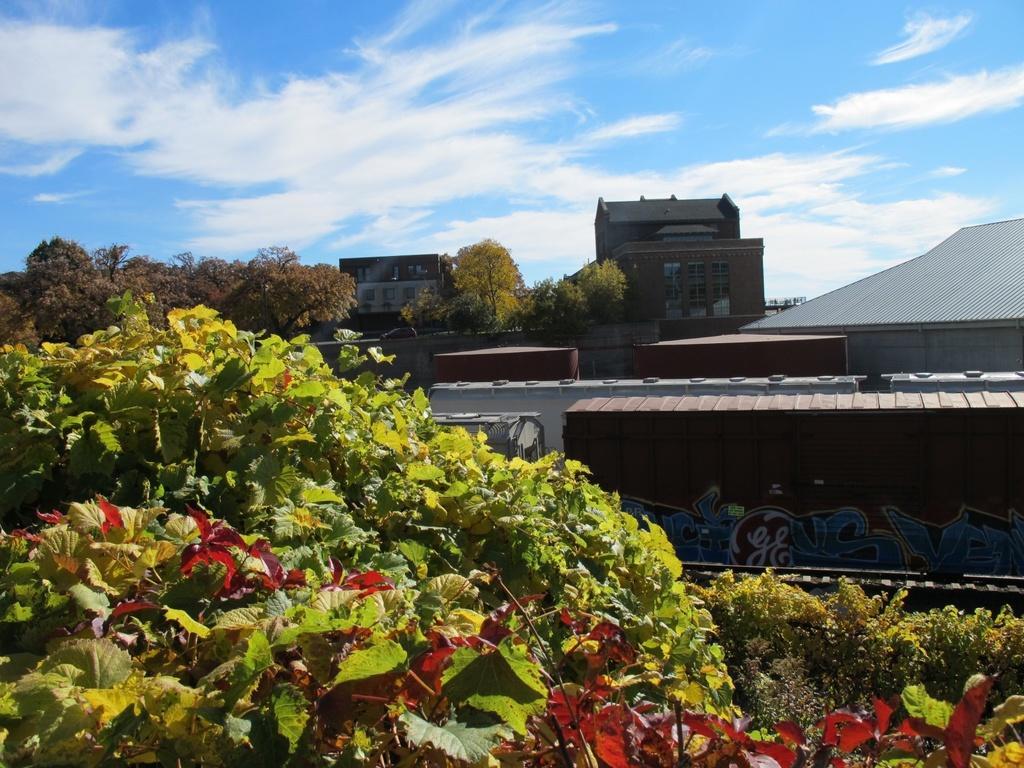Can you describe this image briefly? In this image , in the foreground there are many leaves and on the left side there is a tree and the background is the blue sky. 